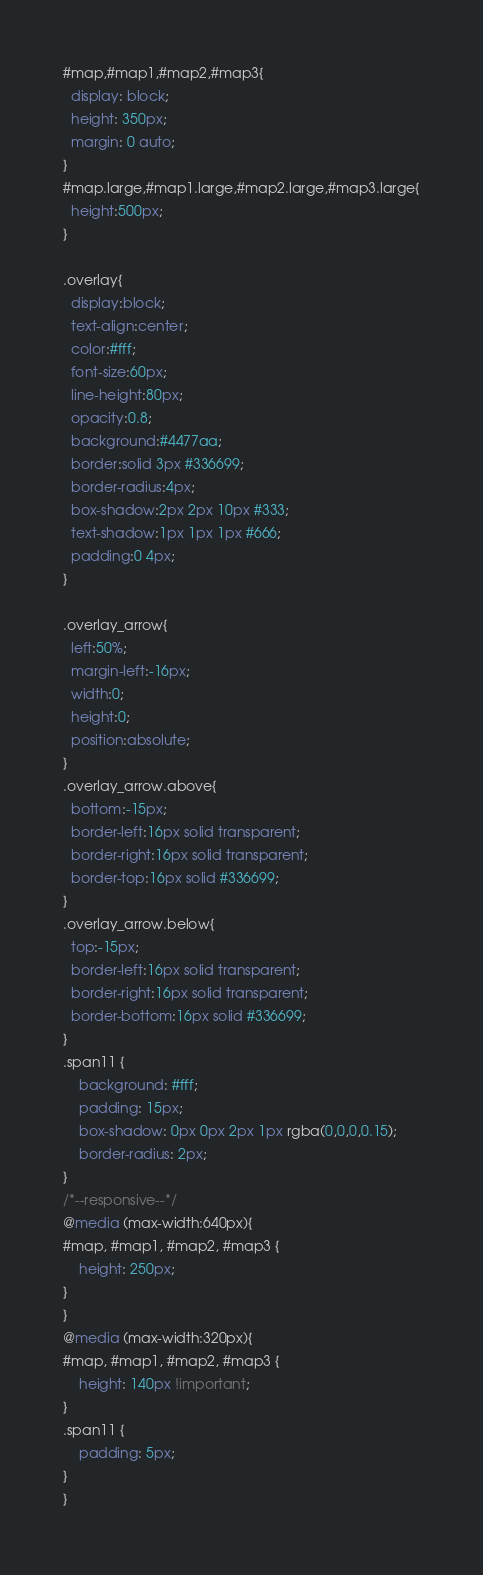Convert code to text. <code><loc_0><loc_0><loc_500><loc_500><_CSS_>
#map,#map1,#map2,#map3{
  display: block;
  height: 350px;
  margin: 0 auto;
}
#map.large,#map1.large,#map2.large,#map3.large{
  height:500px;
}

.overlay{
  display:block;
  text-align:center;
  color:#fff;
  font-size:60px;
  line-height:80px;
  opacity:0.8;
  background:#4477aa;
  border:solid 3px #336699;
  border-radius:4px;
  box-shadow:2px 2px 10px #333;
  text-shadow:1px 1px 1px #666;
  padding:0 4px;
}

.overlay_arrow{
  left:50%;
  margin-left:-16px;
  width:0;
  height:0;
  position:absolute;
}
.overlay_arrow.above{
  bottom:-15px;
  border-left:16px solid transparent;
  border-right:16px solid transparent;
  border-top:16px solid #336699;
}
.overlay_arrow.below{
  top:-15px;
  border-left:16px solid transparent;
  border-right:16px solid transparent;
  border-bottom:16px solid #336699;
}
.span11 {
    background: #fff;
    padding: 15px;
    box-shadow: 0px 0px 2px 1px rgba(0,0,0,0.15);
    border-radius: 2px;
}
/*--responsive--*/
@media (max-width:640px){
#map, #map1, #map2, #map3 {
    height: 250px;
}
}
@media (max-width:320px){
#map, #map1, #map2, #map3 {
    height: 140px !important;
}
.span11 {
    padding: 5px;
}
}</code> 